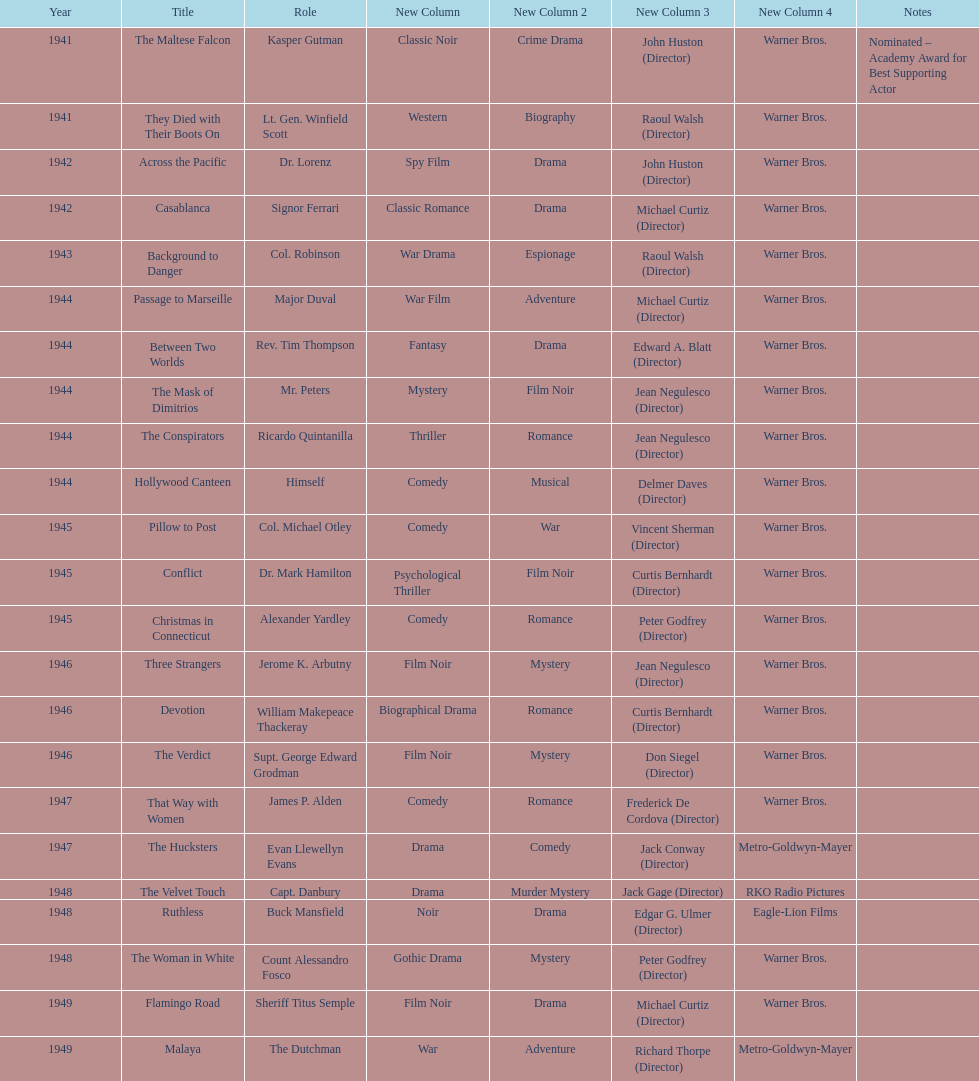How many movies has he been from 1941-1949. 23. 